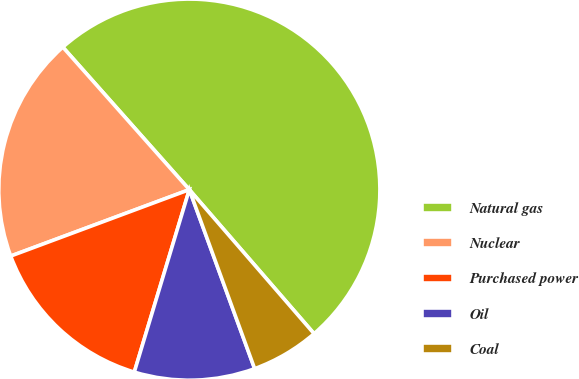<chart> <loc_0><loc_0><loc_500><loc_500><pie_chart><fcel>Natural gas<fcel>Nuclear<fcel>Purchased power<fcel>Oil<fcel>Coal<nl><fcel>50.19%<fcel>19.11%<fcel>14.67%<fcel>10.23%<fcel>5.79%<nl></chart> 